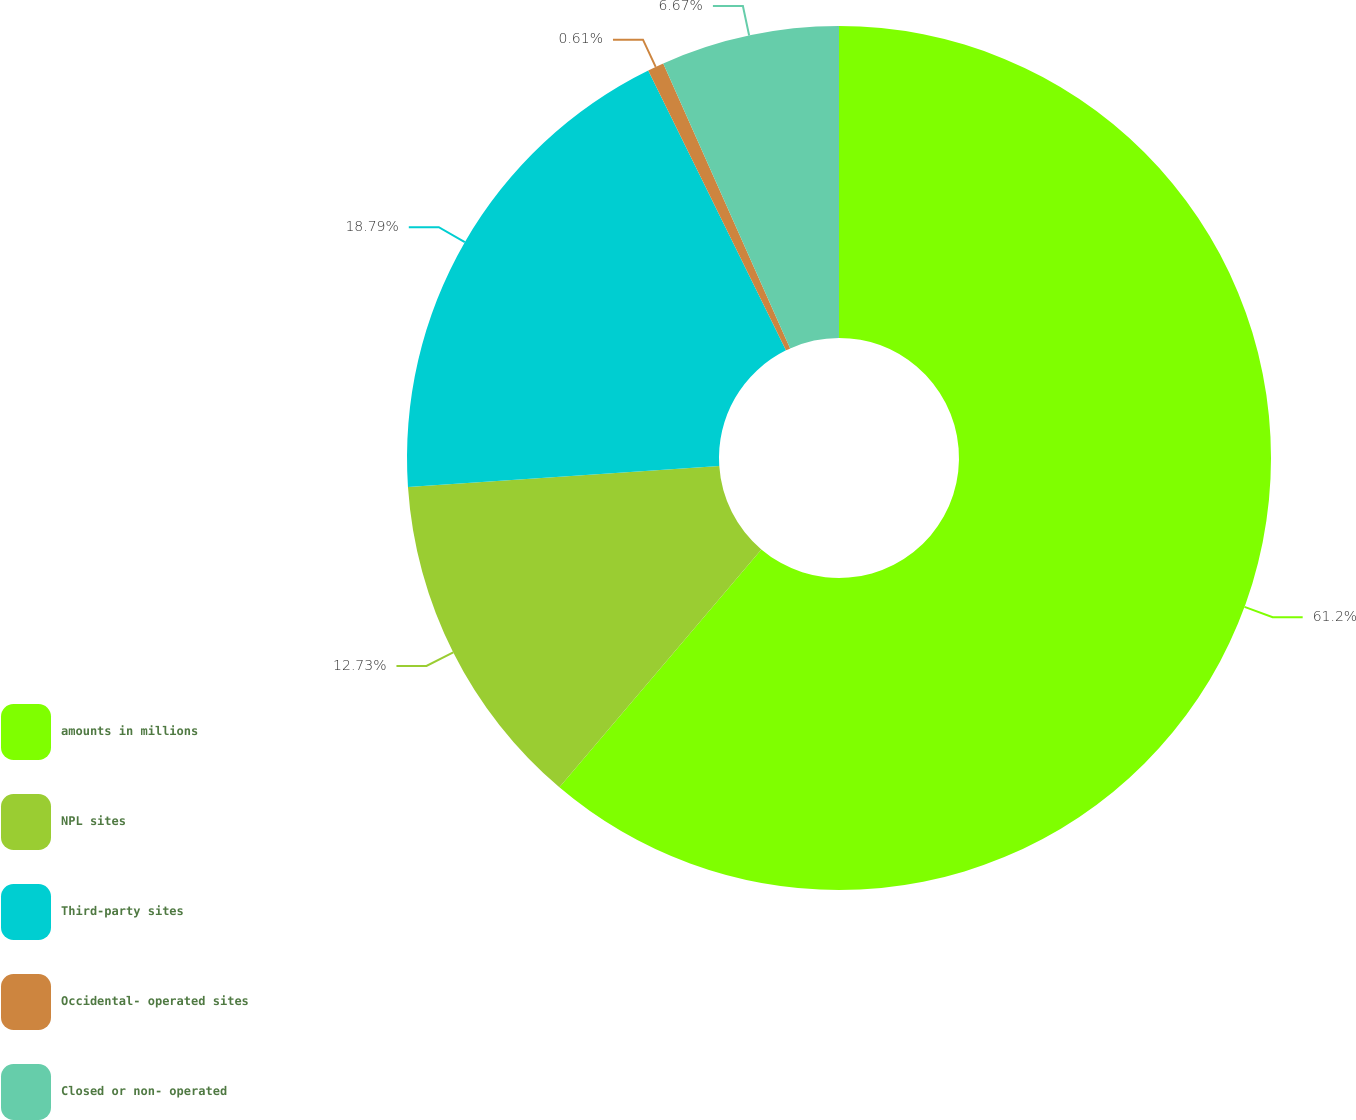Convert chart to OTSL. <chart><loc_0><loc_0><loc_500><loc_500><pie_chart><fcel>amounts in millions<fcel>NPL sites<fcel>Third-party sites<fcel>Occidental- operated sites<fcel>Closed or non- operated<nl><fcel>61.21%<fcel>12.73%<fcel>18.79%<fcel>0.61%<fcel>6.67%<nl></chart> 